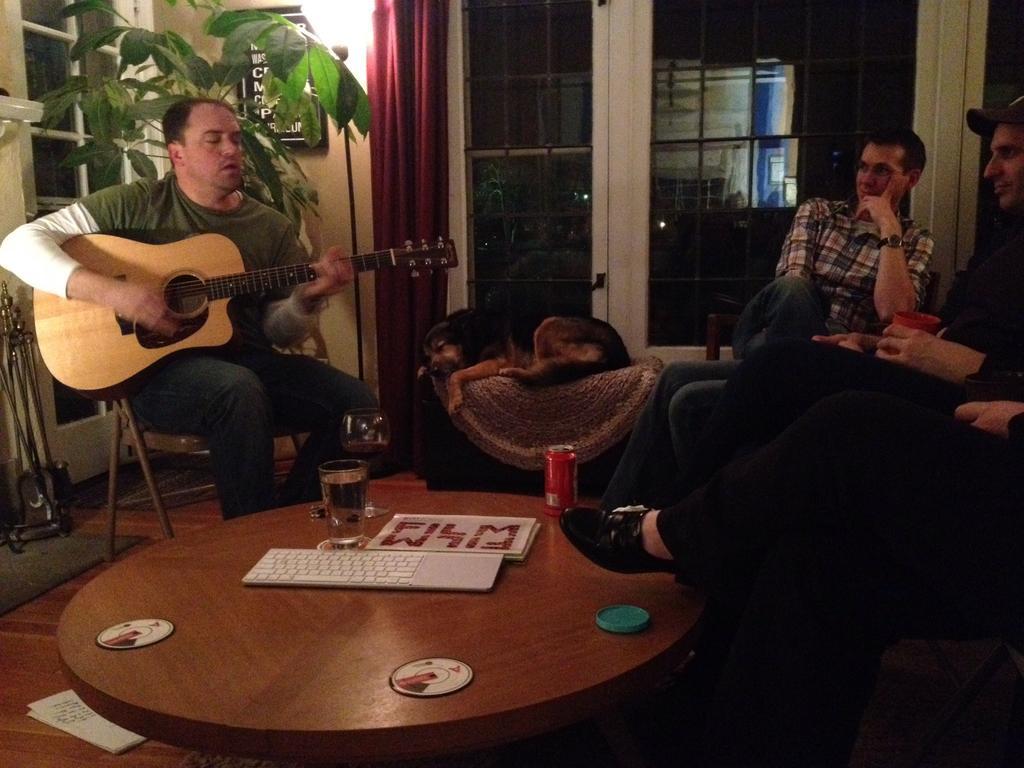Describe this image in one or two sentences. As we can see in the image, there are four people, three on the right and one on the left. The person who is sitting on the left side is holding guitar in his hand and singing. Behind him there is a plant. In the front there is a table. On table there is a keyboard and glass and here there is a black color dog sleeping. 